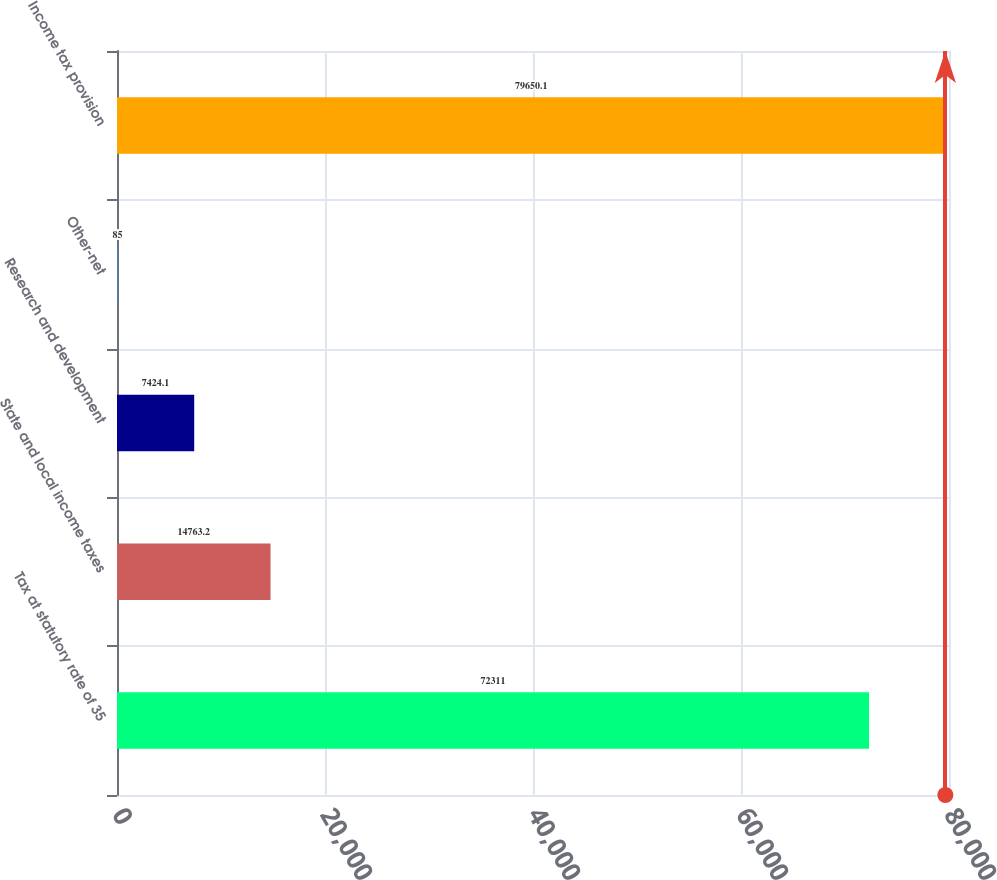<chart> <loc_0><loc_0><loc_500><loc_500><bar_chart><fcel>Tax at statutory rate of 35<fcel>State and local income taxes<fcel>Research and development<fcel>Other-net<fcel>Income tax provision<nl><fcel>72311<fcel>14763.2<fcel>7424.1<fcel>85<fcel>79650.1<nl></chart> 